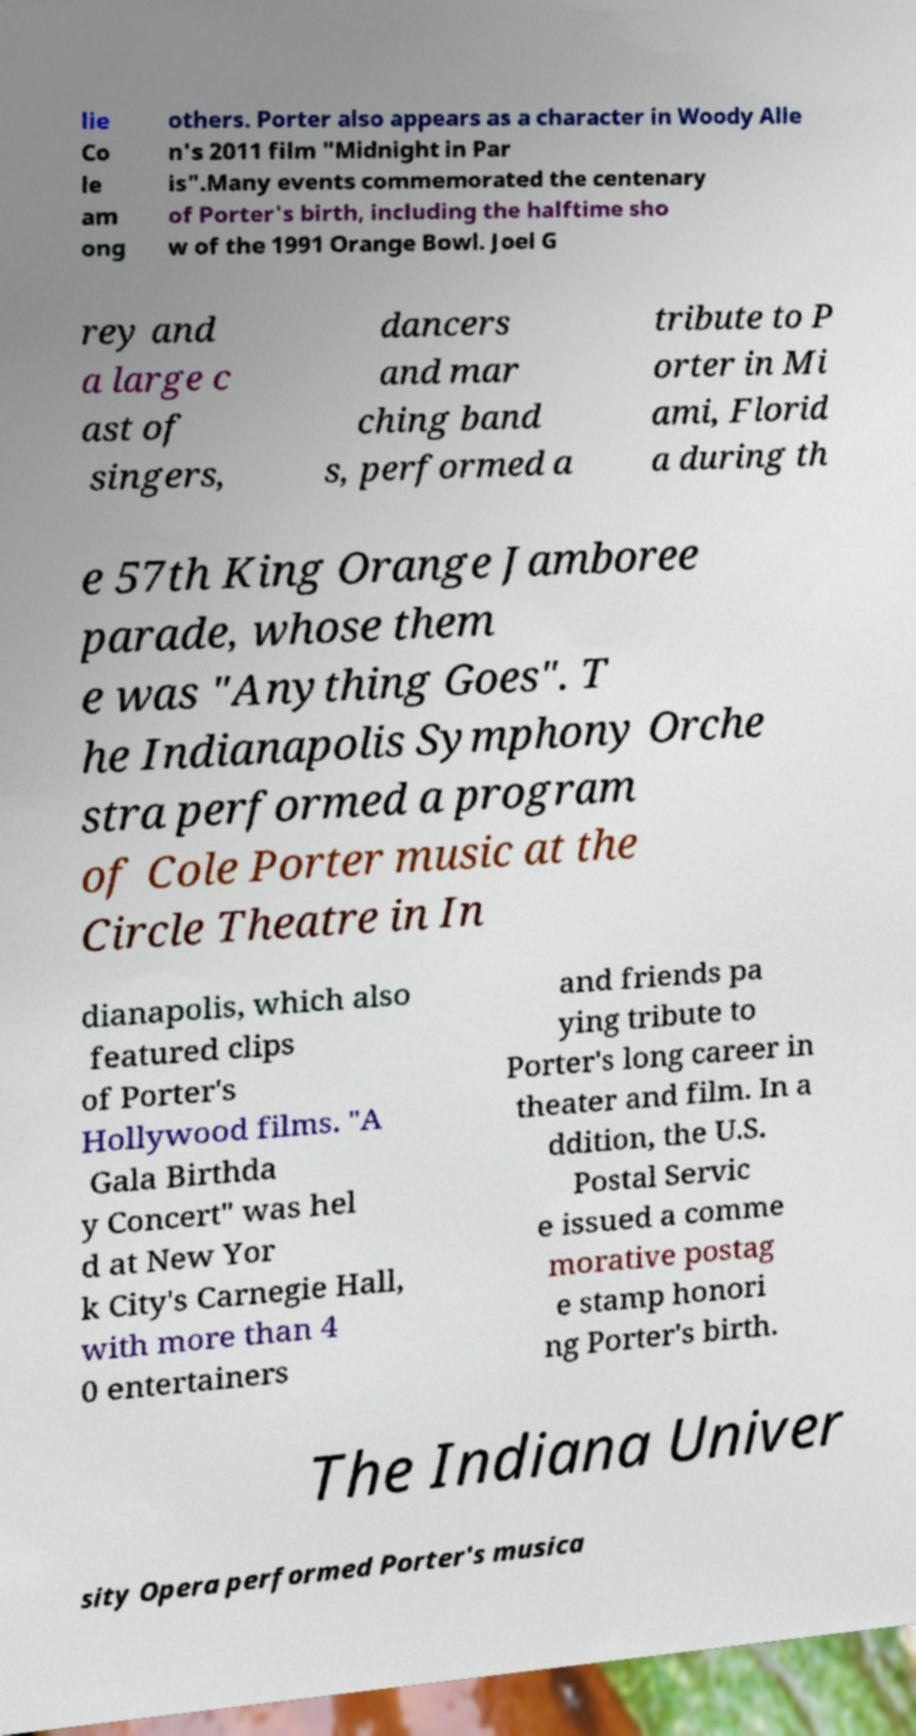Please identify and transcribe the text found in this image. lie Co le am ong others. Porter also appears as a character in Woody Alle n's 2011 film "Midnight in Par is".Many events commemorated the centenary of Porter's birth, including the halftime sho w of the 1991 Orange Bowl. Joel G rey and a large c ast of singers, dancers and mar ching band s, performed a tribute to P orter in Mi ami, Florid a during th e 57th King Orange Jamboree parade, whose them e was "Anything Goes". T he Indianapolis Symphony Orche stra performed a program of Cole Porter music at the Circle Theatre in In dianapolis, which also featured clips of Porter's Hollywood films. "A Gala Birthda y Concert" was hel d at New Yor k City's Carnegie Hall, with more than 4 0 entertainers and friends pa ying tribute to Porter's long career in theater and film. In a ddition, the U.S. Postal Servic e issued a comme morative postag e stamp honori ng Porter's birth. The Indiana Univer sity Opera performed Porter's musica 